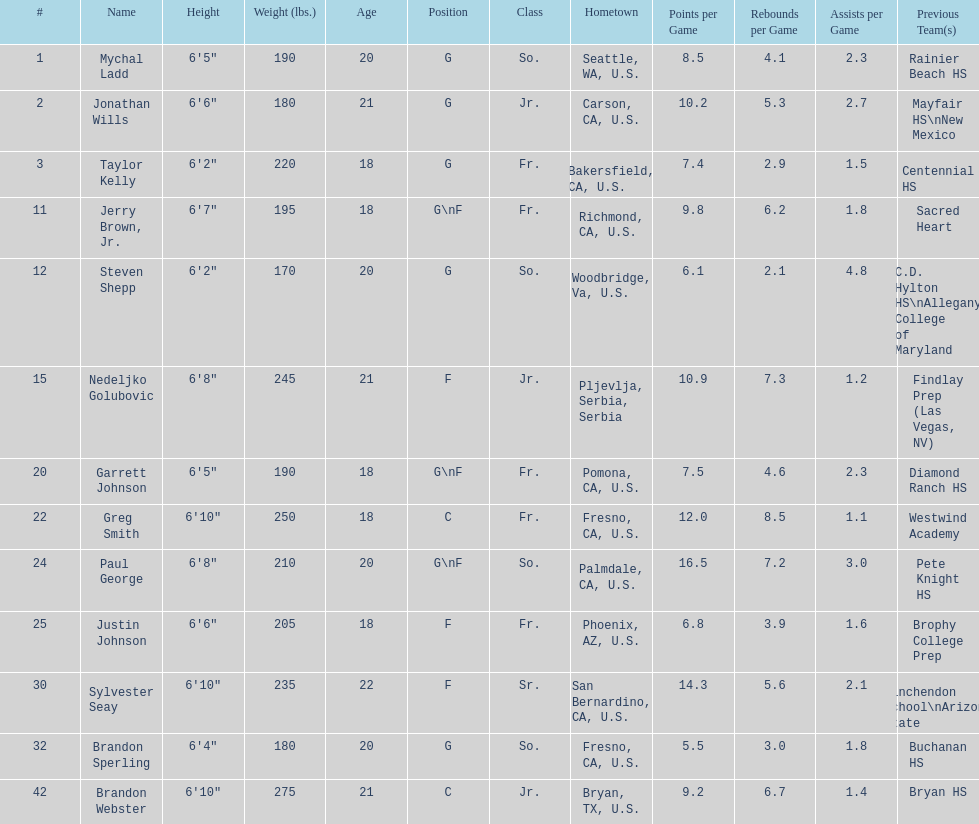Is the number of freshmen (fr.) greater than, equal to, or less than the number of juniors (jr.)? Greater. 